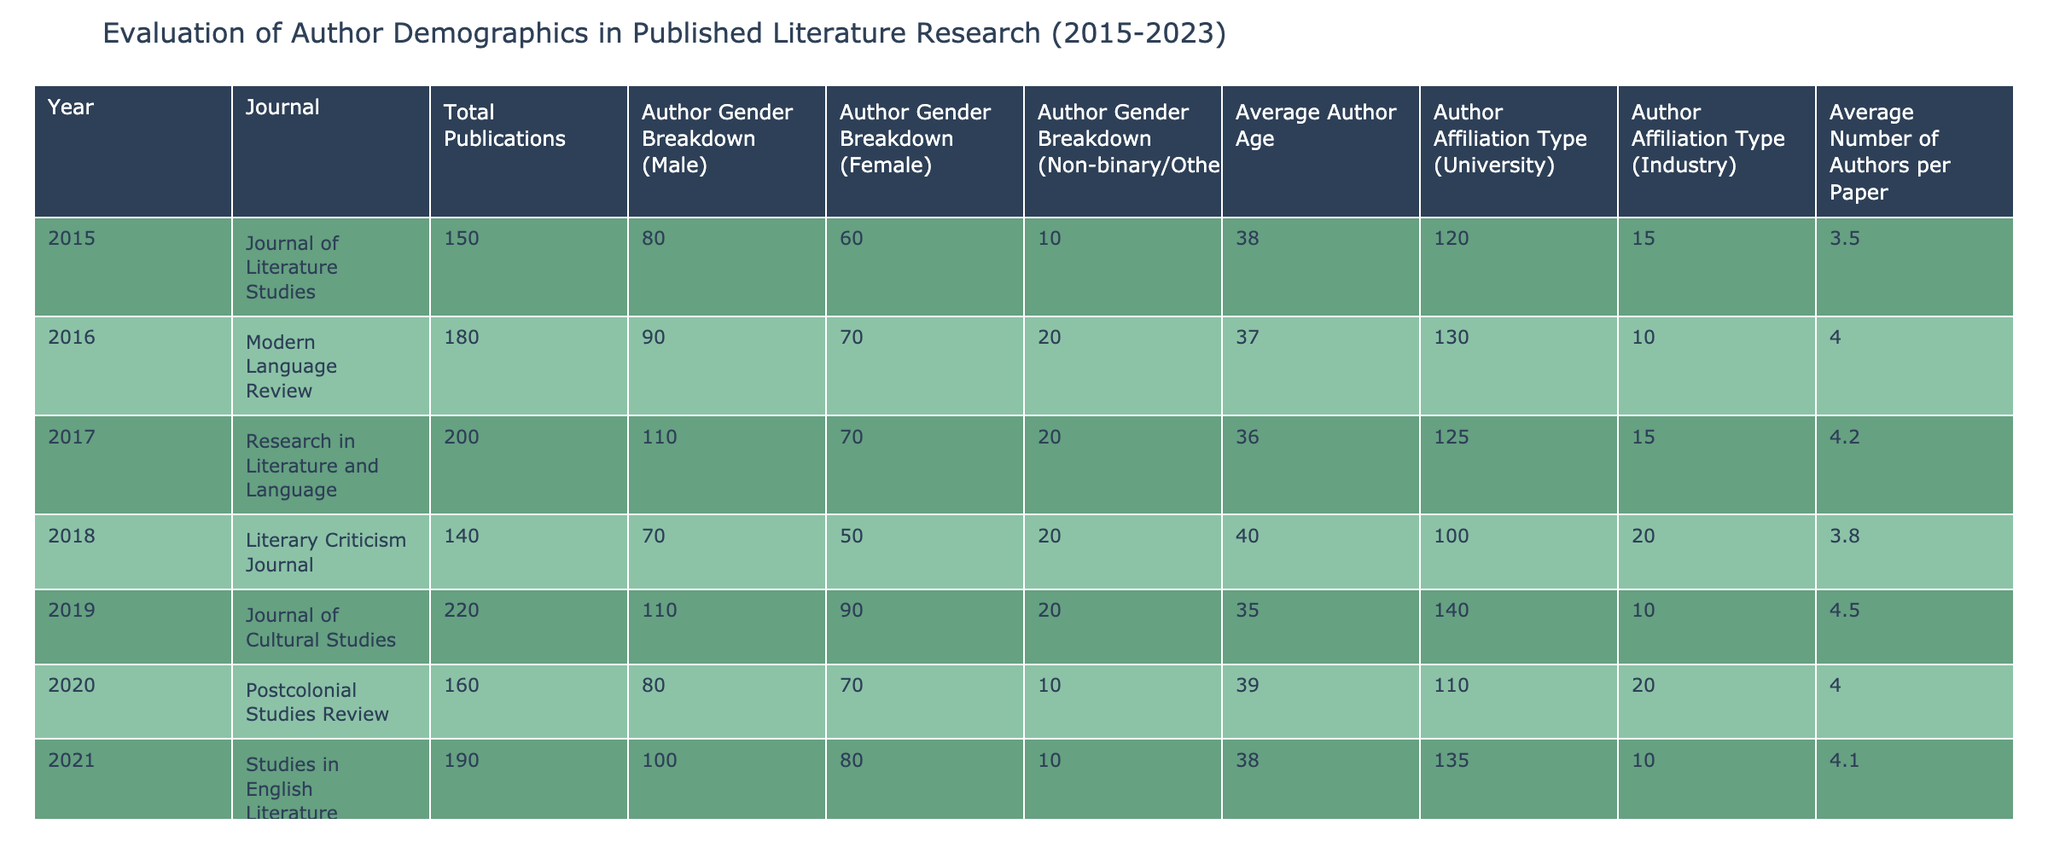What was the total number of publications in 2020? The table shows that in 2020, the "Total Publications" column lists 160 for Postcolonial Studies Review.
Answer: 160 Which year had the highest number of publications? By examining the "Total Publications" column, 2023 shows the highest count of 210 in the Contemporary Literature Journal compared to others.
Answer: 2023 What is the average author age in 2019? The "Average Author Age" column shows that in 2019, the average age listed is 35.
Answer: 35 What is the total number of male authors across all years? To find the total number of male authors, I need to sum the values from the "Author Gender Breakdown (Male)" column: 80 + 90 + 110 + 70 + 110 + 80 + 100 + 85 + 115 = 950.
Answer: 950 Did the average number of authors per paper increase from 2015 to 2023? I compare the "Average Number of Authors per Paper" from 2015 (3.5) to 2023 (4.3). Since 4.3 is greater than 3.5, it indicates an increase.
Answer: Yes What percentage of total publications in 2017 had non-binary/other authors? First, I find the number of non-binary/other authors (20) and total publications (200) in 2017. The percentage is calculated as (20 / 200) * 100 = 10%.
Answer: 10% Which journal had the highest average author age, and what was that age? Looking at the "Average Author Age" column, the highest value is 40 in the Literary Criticism Journal for 2018.
Answer: Literary Criticism Journal, 40 Was the gender breakdown for female authors higher in 2018 than in 2016? From the table, in 2018 there were 50 female authors and in 2016, there were 70. Since 50 is less than 70, the statement is false.
Answer: No How many more male authors were there than non-binary authors in 2017? In 2017, there were 110 male authors and 20 non-binary authors. The difference is 110 - 20 = 90 male authors more than non-binary.
Answer: 90 